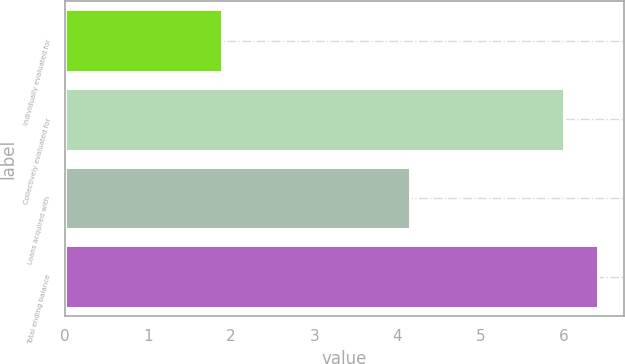Convert chart to OTSL. <chart><loc_0><loc_0><loc_500><loc_500><bar_chart><fcel>Individually evaluated for<fcel>Collectively evaluated for<fcel>Loans acquired with<fcel>Total ending balance<nl><fcel>1.89<fcel>6<fcel>4.15<fcel>6.41<nl></chart> 